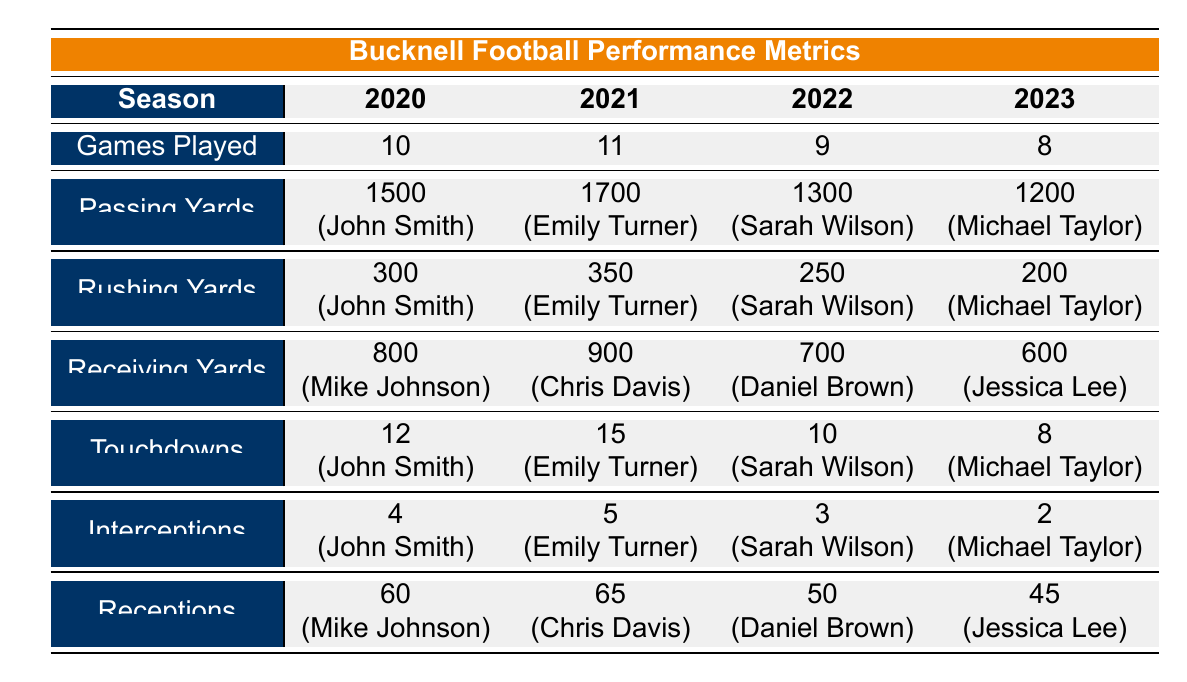What is the total number of games played by all players in the 2021 season? The total number of games played in 2021 consists of the games played by both players: Emily Turner (11 games) and Chris Davis (11 games). Adding these together gives 11 + 11 = 22 games played in total.
Answer: 22 Which player had the highest number of passing yards in a single season? To identify the player with the highest number of passing yards, we compare the passing yards from each season: John Smith (1500), Emily Turner (1700), Sarah Wilson (1300), and Michael Taylor (1200). The highest value among these is 1700, which belongs to Emily Turner.
Answer: Emily Turner Is it true that Sarah Wilson had more touchdowns than Michael Taylor? Sarah Wilson had 10 touchdowns in the 2022 season, while Michael Taylor had 8 touchdowns in 2023. Since 10 is greater than 8, the statement is true.
Answer: Yes What was the average number of touchdowns scored across all seasons? The total touchdowns scored across all four seasons are as follows: 12 (2020) + 15 (2021) + 10 (2022) + 8 (2023) = 45. There are 4 seasons, so the average is calculated by dividing the total by the number of seasons: 45/4 = 11.25.
Answer: 11.25 Which season had the highest number of interceptions? From the table, the interceptions are: 4 in 2020, 5 in 2021, 3 in 2022, and 2 in 2023. The highest number is 5, occurring in the 2021 season.
Answer: 2021 What is the difference in rushing yards between the players with the highest and lowest rushing yards? The player with the highest rushing yards is Emily Turner (350 yards in 2021) and the player with the lowest is Michael Taylor (200 yards in 2023). The difference is calculated as 350 - 200 = 150 yards.
Answer: 150 Did Mike Johnson have more receptions than Daniel Brown? Mike Johnson recorded 60 receptions in 2020, while Daniel Brown recorded 50 receptions in 2022. Since 60 is greater than 50, the response to this question is yes.
Answer: Yes In which season did players score below 10 touchdowns collectively? The total touchdowns per season are: 12 (2020), 15 (2021), 10 (2022), and 8 (2023). The only season where the touchdowns score is below 10 is 2023 with 8 touchdowns.
Answer: 2023 